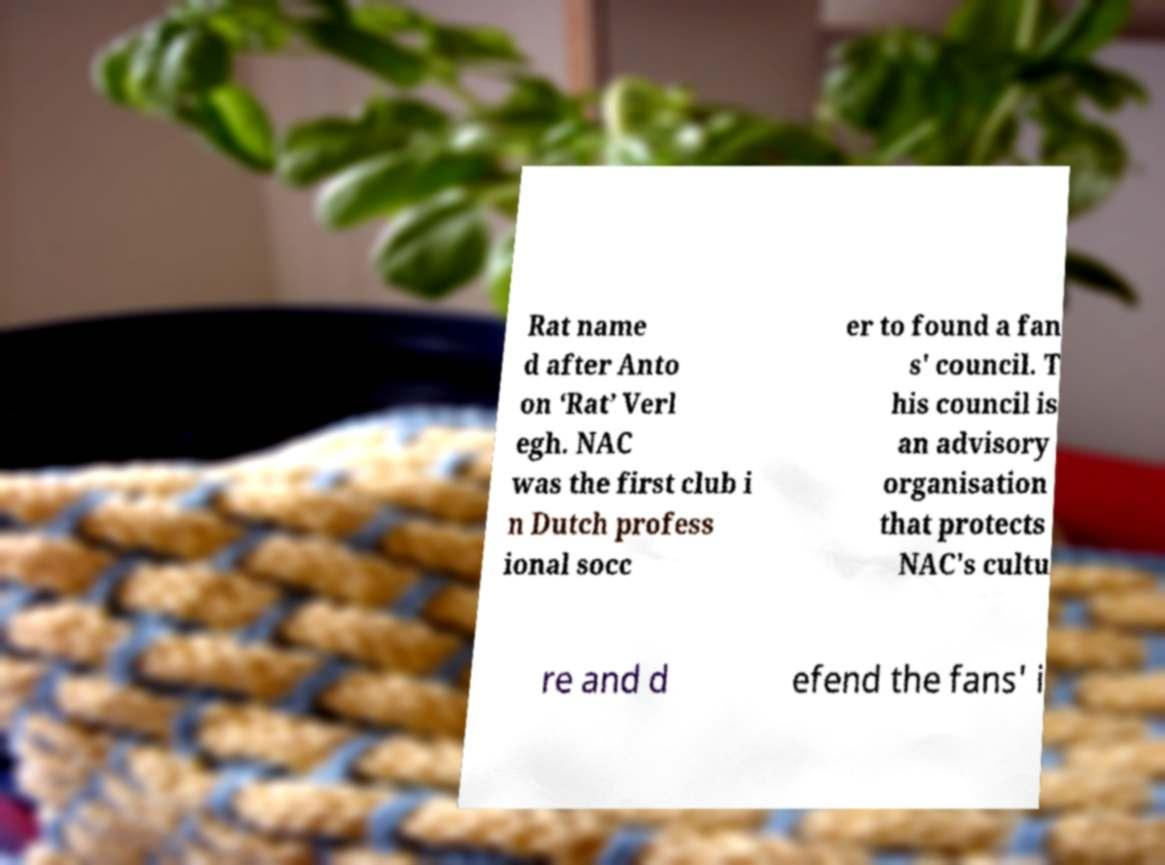There's text embedded in this image that I need extracted. Can you transcribe it verbatim? Rat name d after Anto on ‘Rat’ Verl egh. NAC was the first club i n Dutch profess ional socc er to found a fan s' council. T his council is an advisory organisation that protects NAC's cultu re and d efend the fans' i 